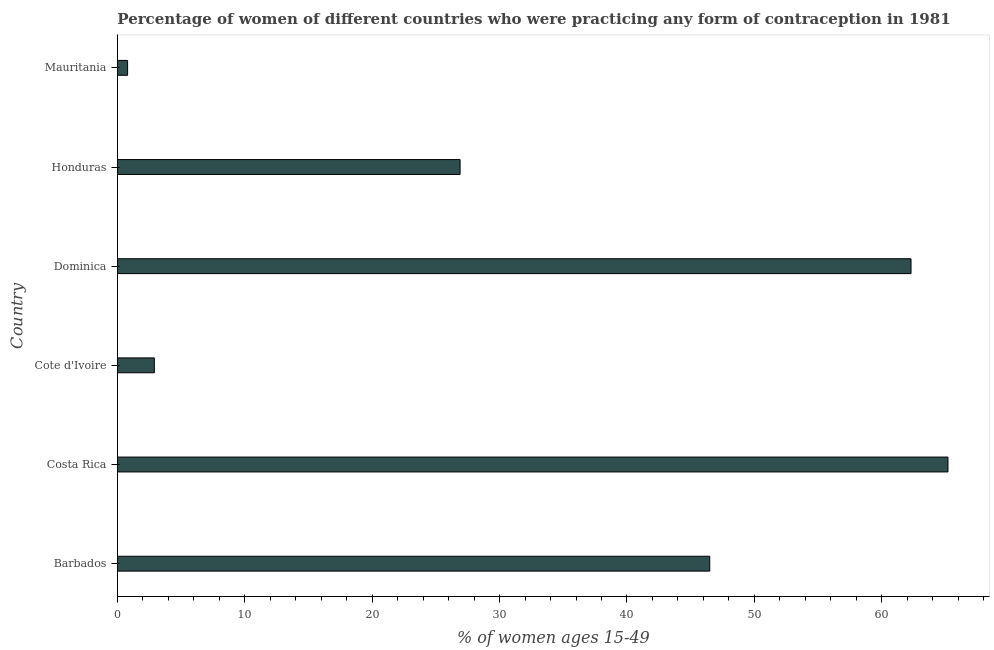Does the graph contain any zero values?
Your response must be concise. No. Does the graph contain grids?
Your answer should be very brief. No. What is the title of the graph?
Your answer should be very brief. Percentage of women of different countries who were practicing any form of contraception in 1981. What is the label or title of the X-axis?
Your answer should be very brief. % of women ages 15-49. What is the label or title of the Y-axis?
Your answer should be compact. Country. What is the contraceptive prevalence in Cote d'Ivoire?
Provide a short and direct response. 2.9. Across all countries, what is the maximum contraceptive prevalence?
Ensure brevity in your answer.  65.2. In which country was the contraceptive prevalence maximum?
Your answer should be compact. Costa Rica. In which country was the contraceptive prevalence minimum?
Offer a very short reply. Mauritania. What is the sum of the contraceptive prevalence?
Offer a terse response. 204.6. What is the average contraceptive prevalence per country?
Give a very brief answer. 34.1. What is the median contraceptive prevalence?
Give a very brief answer. 36.7. In how many countries, is the contraceptive prevalence greater than 44 %?
Offer a terse response. 3. What is the ratio of the contraceptive prevalence in Costa Rica to that in Honduras?
Give a very brief answer. 2.42. Is the difference between the contraceptive prevalence in Barbados and Dominica greater than the difference between any two countries?
Provide a short and direct response. No. Is the sum of the contraceptive prevalence in Barbados and Cote d'Ivoire greater than the maximum contraceptive prevalence across all countries?
Your response must be concise. No. What is the difference between the highest and the lowest contraceptive prevalence?
Your answer should be very brief. 64.4. In how many countries, is the contraceptive prevalence greater than the average contraceptive prevalence taken over all countries?
Provide a short and direct response. 3. How many bars are there?
Your response must be concise. 6. What is the % of women ages 15-49 of Barbados?
Offer a terse response. 46.5. What is the % of women ages 15-49 of Costa Rica?
Your response must be concise. 65.2. What is the % of women ages 15-49 of Cote d'Ivoire?
Give a very brief answer. 2.9. What is the % of women ages 15-49 of Dominica?
Your answer should be compact. 62.3. What is the % of women ages 15-49 of Honduras?
Offer a terse response. 26.9. What is the difference between the % of women ages 15-49 in Barbados and Costa Rica?
Offer a very short reply. -18.7. What is the difference between the % of women ages 15-49 in Barbados and Cote d'Ivoire?
Make the answer very short. 43.6. What is the difference between the % of women ages 15-49 in Barbados and Dominica?
Provide a succinct answer. -15.8. What is the difference between the % of women ages 15-49 in Barbados and Honduras?
Your answer should be very brief. 19.6. What is the difference between the % of women ages 15-49 in Barbados and Mauritania?
Provide a succinct answer. 45.7. What is the difference between the % of women ages 15-49 in Costa Rica and Cote d'Ivoire?
Give a very brief answer. 62.3. What is the difference between the % of women ages 15-49 in Costa Rica and Honduras?
Make the answer very short. 38.3. What is the difference between the % of women ages 15-49 in Costa Rica and Mauritania?
Offer a very short reply. 64.4. What is the difference between the % of women ages 15-49 in Cote d'Ivoire and Dominica?
Provide a succinct answer. -59.4. What is the difference between the % of women ages 15-49 in Cote d'Ivoire and Honduras?
Provide a succinct answer. -24. What is the difference between the % of women ages 15-49 in Cote d'Ivoire and Mauritania?
Offer a very short reply. 2.1. What is the difference between the % of women ages 15-49 in Dominica and Honduras?
Offer a terse response. 35.4. What is the difference between the % of women ages 15-49 in Dominica and Mauritania?
Your answer should be very brief. 61.5. What is the difference between the % of women ages 15-49 in Honduras and Mauritania?
Provide a short and direct response. 26.1. What is the ratio of the % of women ages 15-49 in Barbados to that in Costa Rica?
Make the answer very short. 0.71. What is the ratio of the % of women ages 15-49 in Barbados to that in Cote d'Ivoire?
Your answer should be very brief. 16.03. What is the ratio of the % of women ages 15-49 in Barbados to that in Dominica?
Offer a very short reply. 0.75. What is the ratio of the % of women ages 15-49 in Barbados to that in Honduras?
Keep it short and to the point. 1.73. What is the ratio of the % of women ages 15-49 in Barbados to that in Mauritania?
Your answer should be very brief. 58.12. What is the ratio of the % of women ages 15-49 in Costa Rica to that in Cote d'Ivoire?
Offer a terse response. 22.48. What is the ratio of the % of women ages 15-49 in Costa Rica to that in Dominica?
Your answer should be compact. 1.05. What is the ratio of the % of women ages 15-49 in Costa Rica to that in Honduras?
Keep it short and to the point. 2.42. What is the ratio of the % of women ages 15-49 in Costa Rica to that in Mauritania?
Keep it short and to the point. 81.5. What is the ratio of the % of women ages 15-49 in Cote d'Ivoire to that in Dominica?
Ensure brevity in your answer.  0.05. What is the ratio of the % of women ages 15-49 in Cote d'Ivoire to that in Honduras?
Give a very brief answer. 0.11. What is the ratio of the % of women ages 15-49 in Cote d'Ivoire to that in Mauritania?
Provide a short and direct response. 3.62. What is the ratio of the % of women ages 15-49 in Dominica to that in Honduras?
Offer a terse response. 2.32. What is the ratio of the % of women ages 15-49 in Dominica to that in Mauritania?
Give a very brief answer. 77.88. What is the ratio of the % of women ages 15-49 in Honduras to that in Mauritania?
Give a very brief answer. 33.62. 